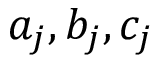Convert formula to latex. <formula><loc_0><loc_0><loc_500><loc_500>a _ { j } , b _ { j } , c _ { j }</formula> 